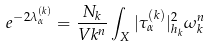<formula> <loc_0><loc_0><loc_500><loc_500>e ^ { - 2 \lambda _ { \alpha } ^ { ( k ) } } = \frac { N _ { k } } { V k ^ { n } } \int _ { X } | \tau _ { \alpha } ^ { ( k ) } | _ { h _ { k } } ^ { 2 } \omega _ { k } ^ { n }</formula> 